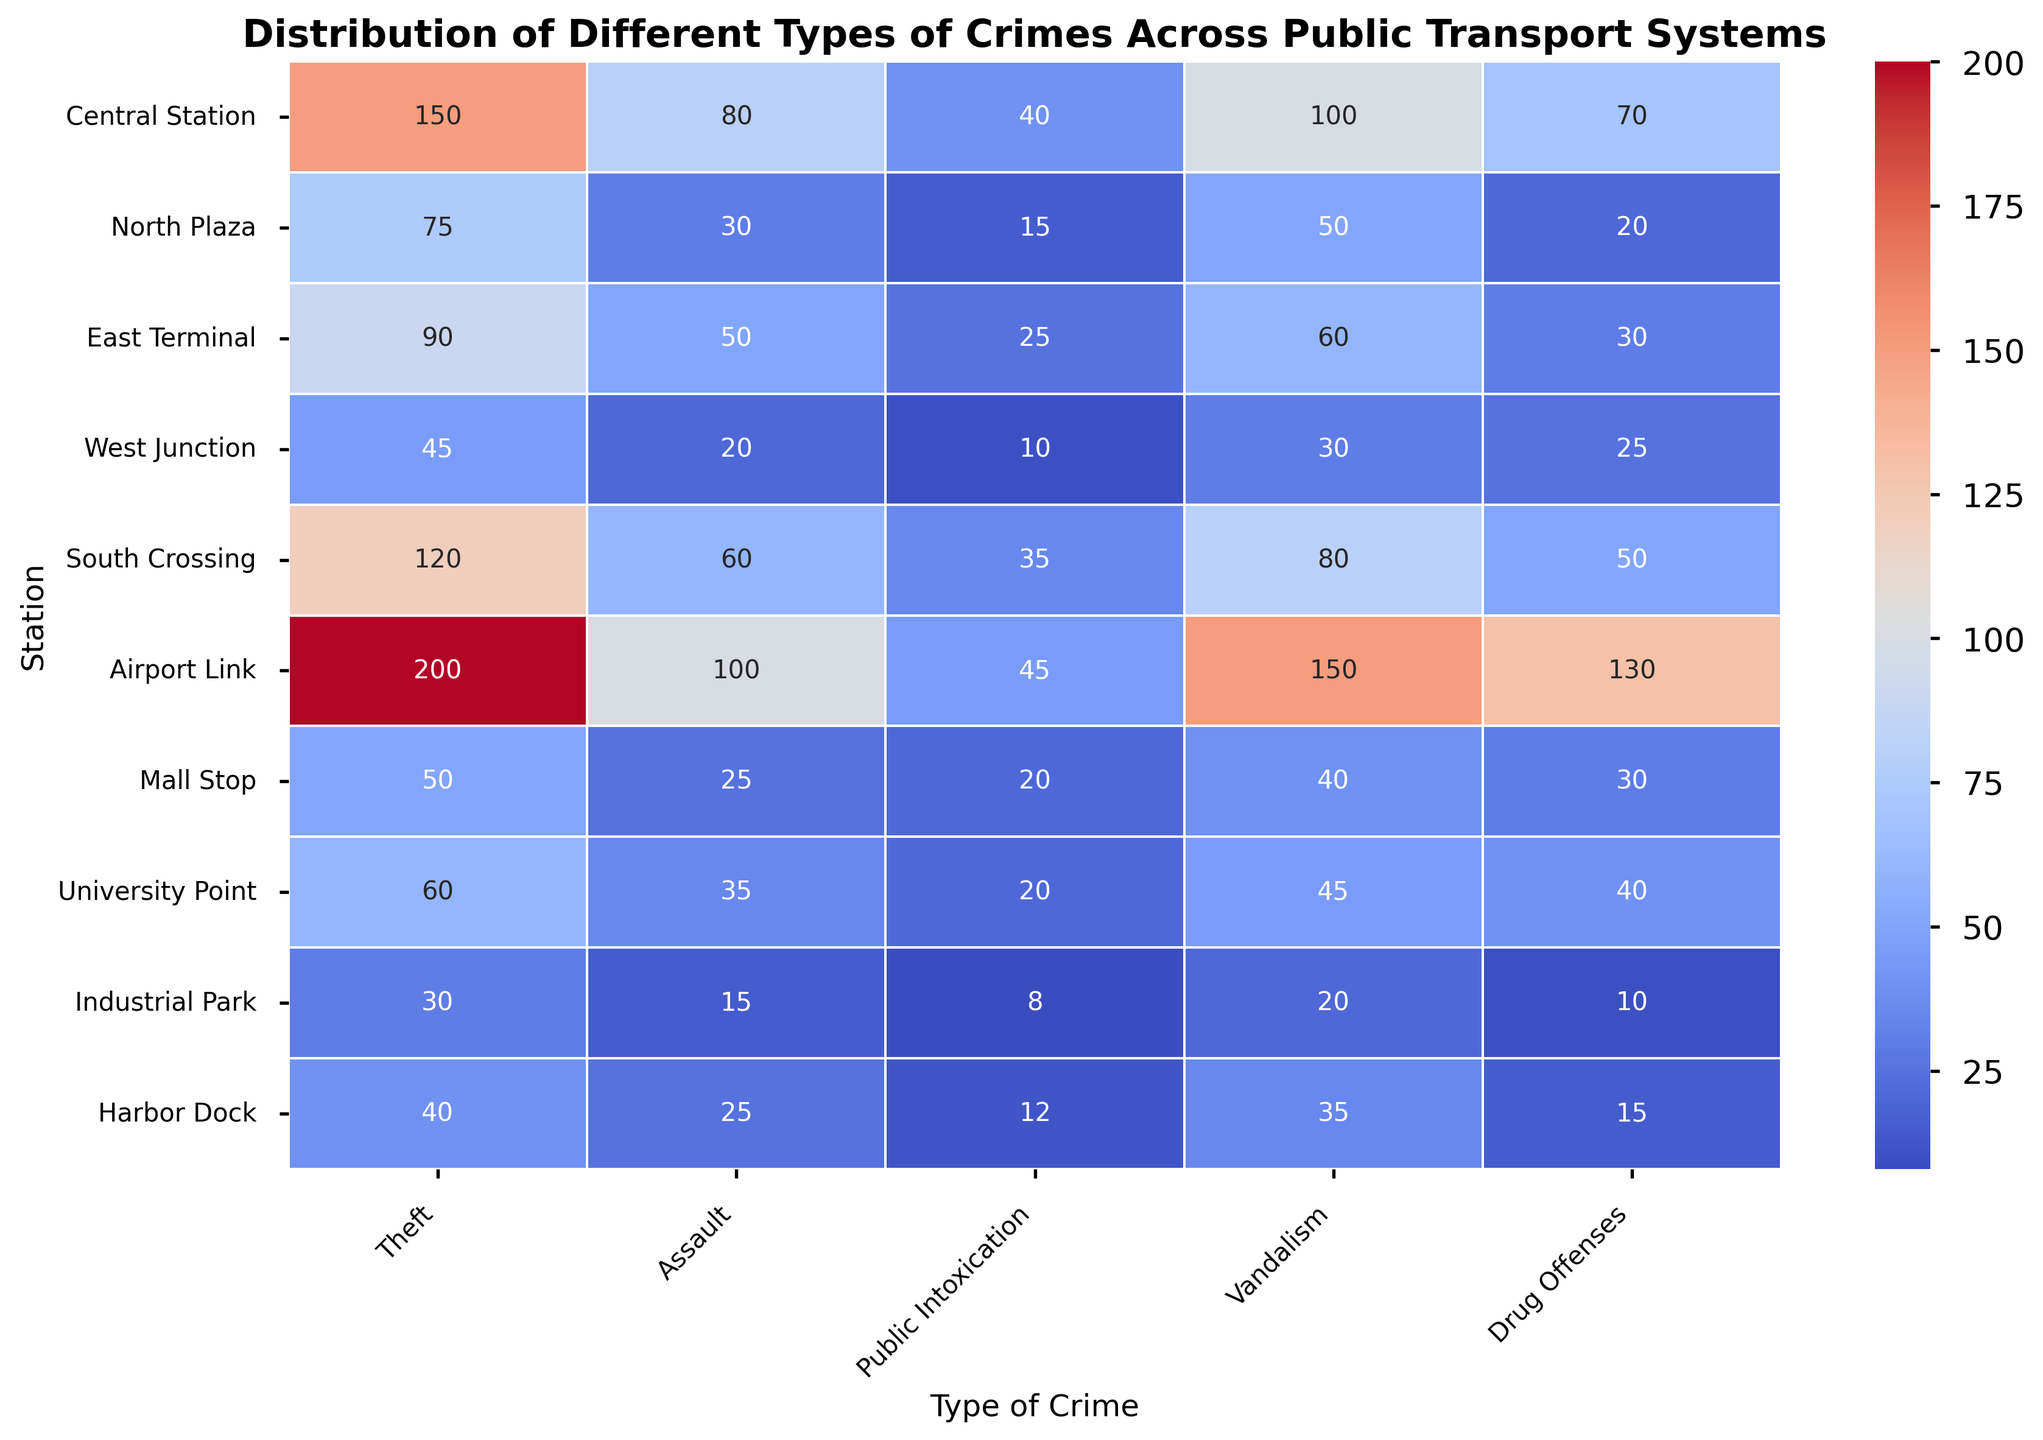What's the station with the highest number of theft incidents? Look at the 'Theft' column and find the highest value. The highest value is 200, located at 'Airport Link'.
Answer: Airport Link Which station has more assault incidents, North Plaza or West Junction? Compare the number of 'Assault' incidents between 'North Plaza' (30) and 'West Junction' (20). 30 is greater than 20.
Answer: North Plaza What is the average number of vandalism incidents across all stations? Sum all the 'Vandalism' incidents and divide by the number of stations. (100 + 50 + 60 + 30 + 80 + 150 + 40 + 45 + 20 + 35) / 10 = 610 / 10 = 61
Answer: 61 Which station has the least number of total incidents? Refer to the 'Total Incidents' column and find the smallest value. The smallest value is 83, located at 'Industrial Park'.
Answer: Industrial Park What is the sum of theft and assault incidents at Central Station? Sum the values in the 'Theft' and 'Assault' columns for 'Central Station'. 150 (Theft) + 80 (Assault) = 230
Answer: 230 How do the number of public intoxication incidents at South Crossing compare to those at Harbor Dock? Compare the values in the 'Public Intoxication' column for 'South Crossing' (35) and 'Harbor Dock' (12). 35 is greater.
Answer: South Crossing has more Which type of crime has the highest overall number of incidents across all stations? Compare the total incidents for each crime type across all stations. 'Theft' has the highest total: 860 (sum of all theft incidents).
Answer: Theft What is the median number of drug offenses across all stations? List all the 'Drug Offenses' values, sort them, and find the middle value. Sorted values: [10, 15, 20, 25, 30, 40, 50, 70, 90, 130]. Middle values are 30 and 40, median is (30+40)/2 = 35
Answer: 35 